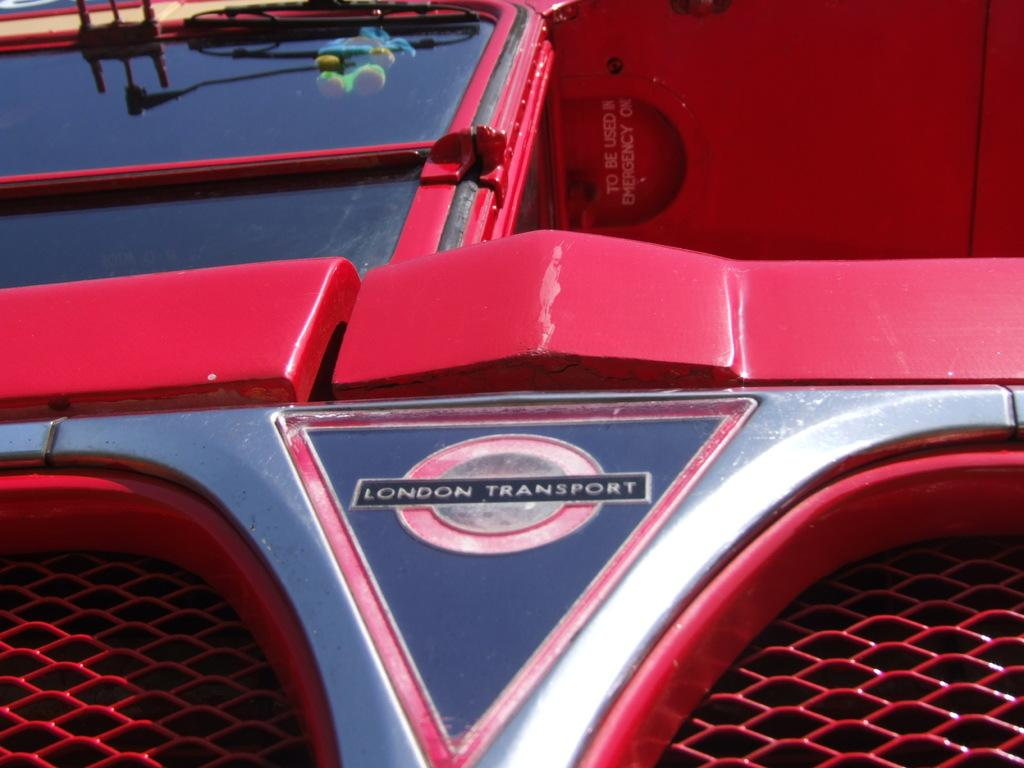What is the main subject of the image? There is a vehicle in the image. What else can be seen in the image besides the vehicle? There is a logo in the image. Can you describe the logo? The logo has text on it. What type of cream can be seen being used by the toys in the image? There are no toys or cream present in the image. Are there any police officers visible in the image? There is no mention of police officers in the provided facts, so we cannot determine their presence in the image. 